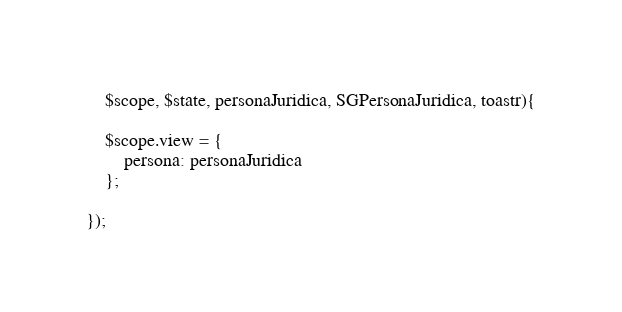<code> <loc_0><loc_0><loc_500><loc_500><_JavaScript_>    $scope, $state, personaJuridica, SGPersonaJuridica, toastr){

    $scope.view = {
        persona: personaJuridica
    };

});

</code> 